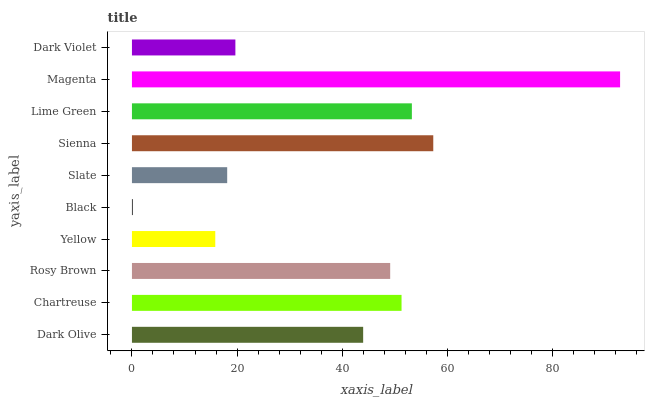Is Black the minimum?
Answer yes or no. Yes. Is Magenta the maximum?
Answer yes or no. Yes. Is Chartreuse the minimum?
Answer yes or no. No. Is Chartreuse the maximum?
Answer yes or no. No. Is Chartreuse greater than Dark Olive?
Answer yes or no. Yes. Is Dark Olive less than Chartreuse?
Answer yes or no. Yes. Is Dark Olive greater than Chartreuse?
Answer yes or no. No. Is Chartreuse less than Dark Olive?
Answer yes or no. No. Is Rosy Brown the high median?
Answer yes or no. Yes. Is Dark Olive the low median?
Answer yes or no. Yes. Is Chartreuse the high median?
Answer yes or no. No. Is Yellow the low median?
Answer yes or no. No. 